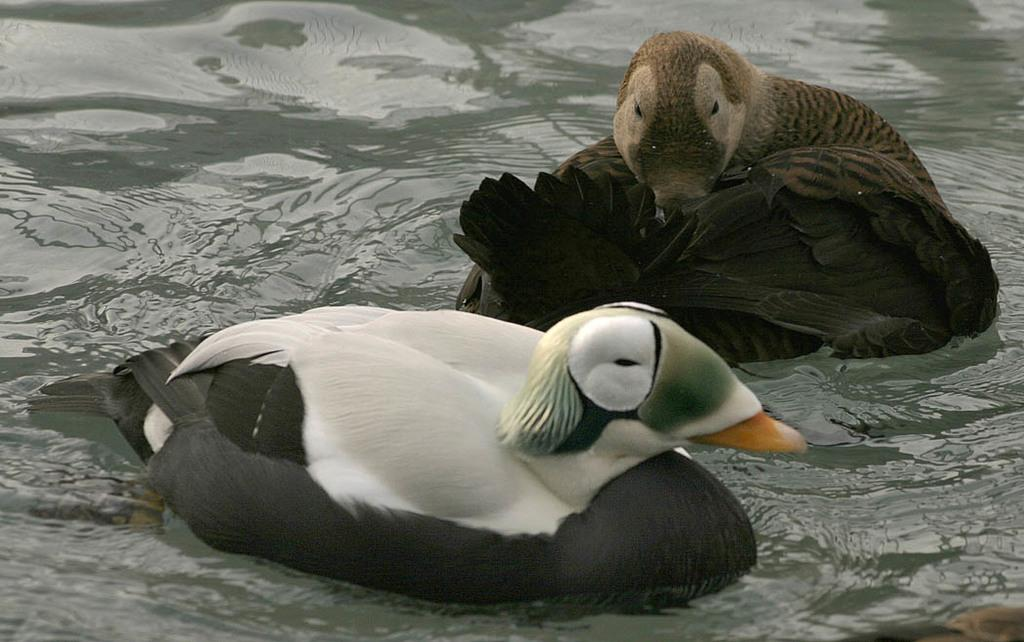What animals are present in the image? There are two birds in the image. Where are the birds located in the image? The birds are on the water. What colors can be seen on the birds in the image? The birds are in white, gray, and brown colors. What type of instrument is being played by the birds in the image? There is no instrument present in the image, as it features two birds on the water. Can you tell me where the map is located in the image? There is no map present in the image. 